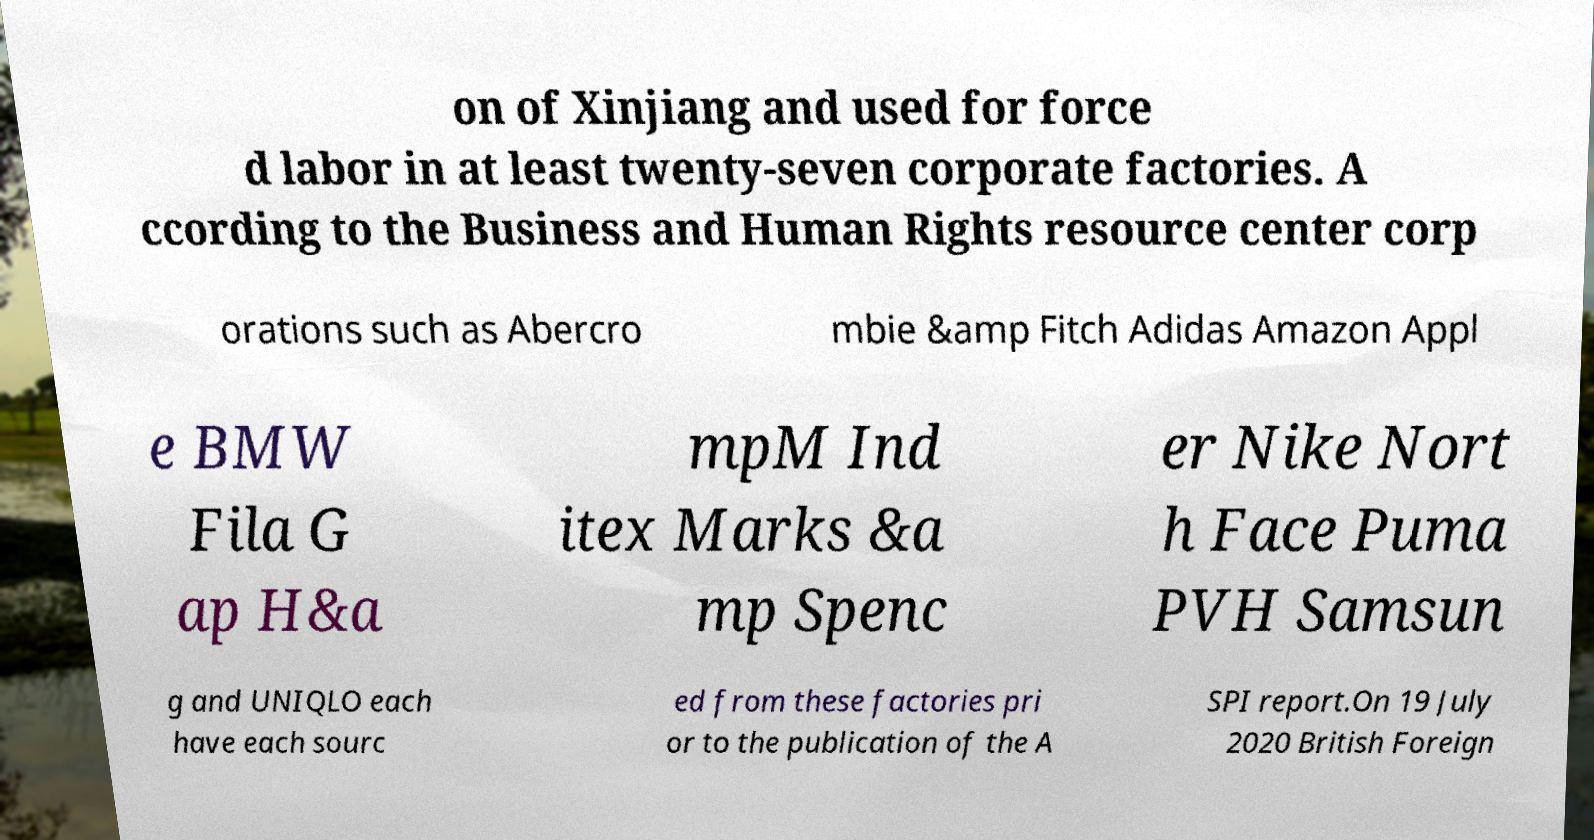Can you read and provide the text displayed in the image?This photo seems to have some interesting text. Can you extract and type it out for me? on of Xinjiang and used for force d labor in at least twenty-seven corporate factories. A ccording to the Business and Human Rights resource center corp orations such as Abercro mbie &amp Fitch Adidas Amazon Appl e BMW Fila G ap H&a mpM Ind itex Marks &a mp Spenc er Nike Nort h Face Puma PVH Samsun g and UNIQLO each have each sourc ed from these factories pri or to the publication of the A SPI report.On 19 July 2020 British Foreign 